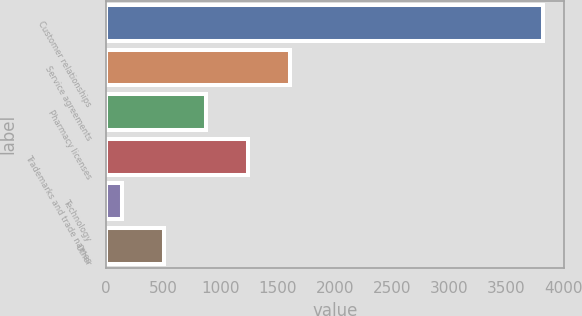Convert chart to OTSL. <chart><loc_0><loc_0><loc_500><loc_500><bar_chart><fcel>Customer relationships<fcel>Service agreements<fcel>Pharmacy licenses<fcel>Trademarks and trade names<fcel>Technology<fcel>Other<nl><fcel>3818<fcel>1611.8<fcel>876.4<fcel>1244.1<fcel>141<fcel>508.7<nl></chart> 